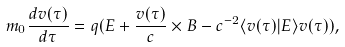Convert formula to latex. <formula><loc_0><loc_0><loc_500><loc_500>m _ { 0 } \frac { d v ( \tau ) } { d \tau } = q ( E + \frac { v ( \tau ) } { c } \times B - c ^ { - 2 } \langle v ( \tau ) | E \rangle v ( \tau ) ) ,</formula> 